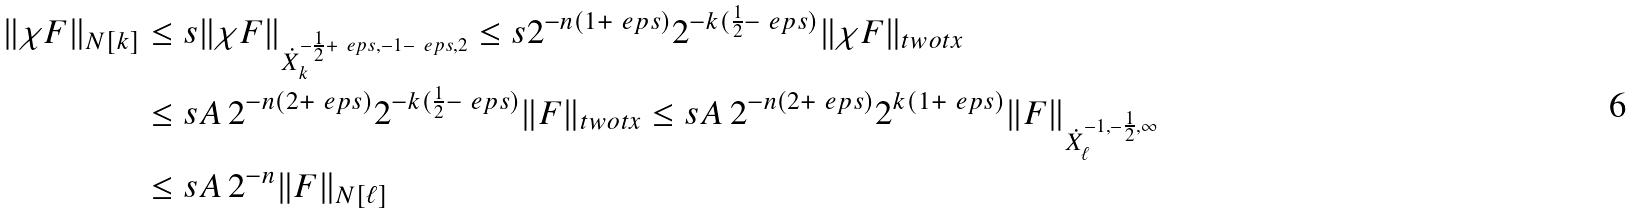Convert formula to latex. <formula><loc_0><loc_0><loc_500><loc_500>\| \chi F \| _ { N [ k ] } & \leq s \| \chi F \| _ { \dot { X } _ { k } ^ { - \frac { 1 } { 2 } + \ e p s , - 1 - \ e p s , 2 } } \leq s 2 ^ { - n ( 1 + \ e p s ) } 2 ^ { - k ( \frac { 1 } { 2 } - \ e p s ) } \| \chi F \| _ { \L t w o t x } \\ & \leq s A \, 2 ^ { - n ( 2 + \ e p s ) } 2 ^ { - k ( \frac { 1 } { 2 } - \ e p s ) } \| F \| _ { \L t w o t x } \leq s A \, 2 ^ { - n ( 2 + \ e p s ) } 2 ^ { k ( 1 + \ e p s ) } \| F \| _ { \dot { X } _ { \ell } ^ { - 1 , - \frac { 1 } { 2 } , \infty } } \\ & \leq s A \, 2 ^ { - n } \| F \| _ { N [ \ell ] }</formula> 